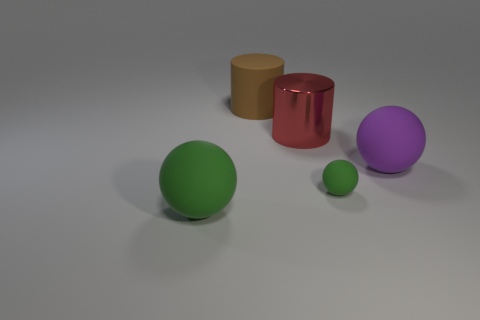There is a matte object that is both behind the tiny green rubber object and on the right side of the large brown cylinder; what size is it?
Your answer should be compact. Large. There is a big thing on the right side of the green object that is on the right side of the large red metallic cylinder; what is its shape?
Your answer should be very brief. Sphere. Are there any other things that are the same shape as the large brown object?
Ensure brevity in your answer.  Yes. Are there an equal number of big red metallic things that are on the left side of the big green ball and big brown rubber objects?
Provide a short and direct response. No. There is a large matte cylinder; is its color the same as the big ball that is behind the big green thing?
Your answer should be compact. No. What is the color of the matte sphere that is on the right side of the big metallic cylinder and in front of the purple thing?
Your response must be concise. Green. How many big purple rubber spheres are behind the purple matte thing that is in front of the brown rubber object?
Provide a succinct answer. 0. Is there a gray shiny object that has the same shape as the large brown object?
Provide a succinct answer. No. There is a matte object in front of the small green rubber sphere; is its shape the same as the big object right of the small matte object?
Your response must be concise. Yes. How many objects are either large green rubber balls or large things?
Your answer should be very brief. 4. 